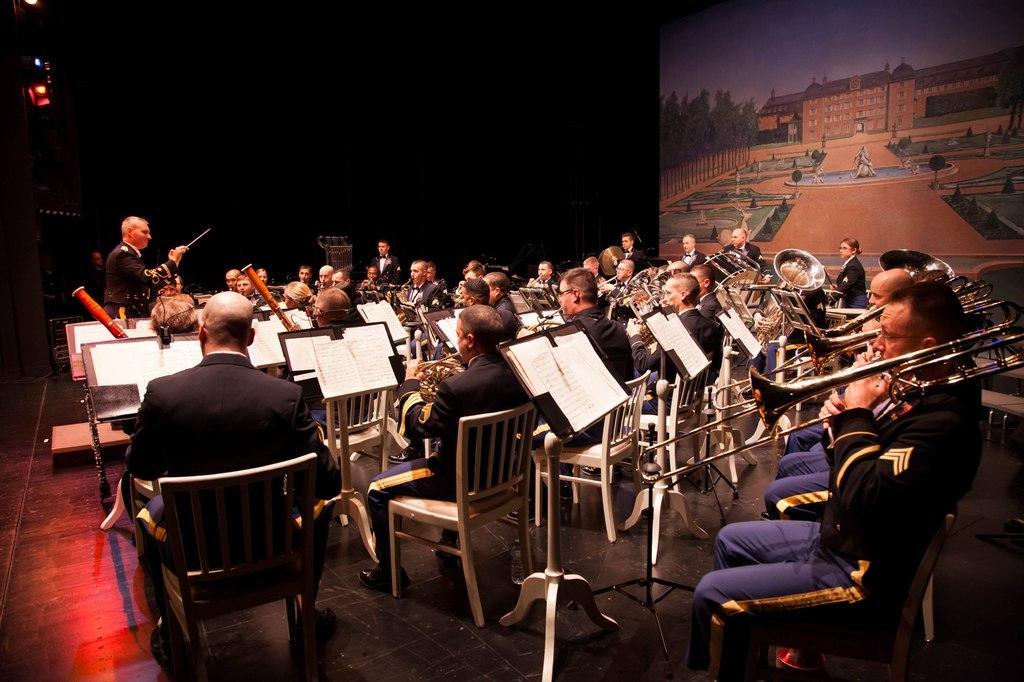Can you describe this image briefly? It is an orchestra playing to the notes of the instructor. 